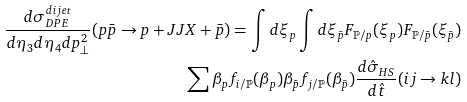Convert formula to latex. <formula><loc_0><loc_0><loc_500><loc_500>\frac { d \sigma _ { D P E } ^ { d i j e t } } { d \eta _ { 3 } d \eta _ { 4 } d p _ { \perp } ^ { 2 } } ( p \bar { p } \to p + J J X + \bar { p } ) = \int d \xi _ { p } \int d \xi _ { \bar { p } } F _ { \mathbb { P } / p } ( \xi _ { p } ) F _ { \mathbb { P } / \bar { p } } ( \xi _ { \bar { p } } ) \\ \sum \beta _ { p } f _ { i / \mathbb { P } } ( \beta _ { p } ) \beta _ { \bar { p } } f _ { j / \mathbb { P } } ( \beta _ { \bar { p } } ) \frac { d \hat { \sigma } _ { H S } } { d \hat { t } } ( i j \to k l )</formula> 